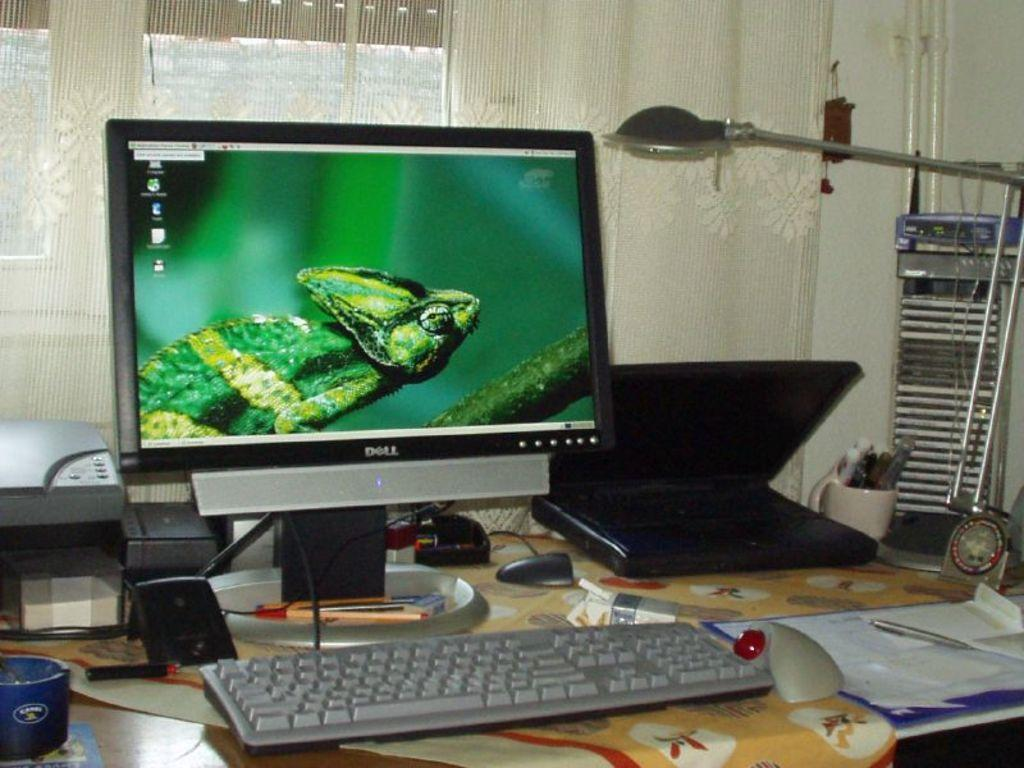<image>
Share a concise interpretation of the image provided. The desk has a Dell monitor on it that has a green lizard on the screen. 